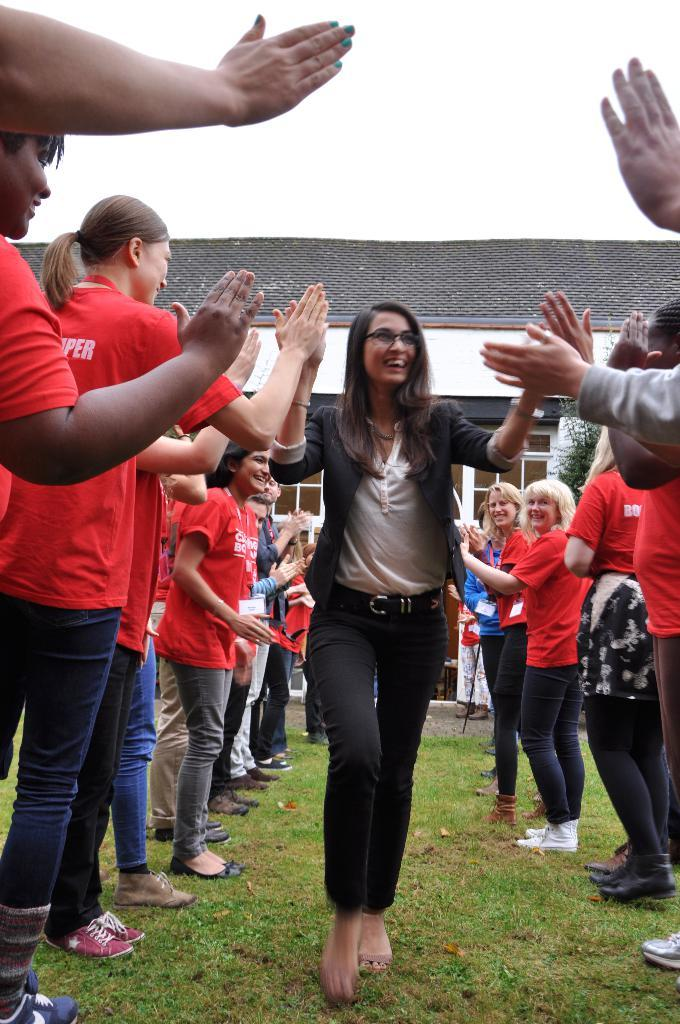What is the main subject of the image? The main subject of the image is a crowd. What is the landscape like in the image? The land is covered with grass. What can be seen in the background of the image? There is a house in the background of the image. What type of windows does the house have? The house has glass windows. How does the maid interact with the crowd in the image? There is no maid present in the image. What type of peace is depicted in the image? The image does not depict any specific type of peace; it features a crowd and a house in the background. 